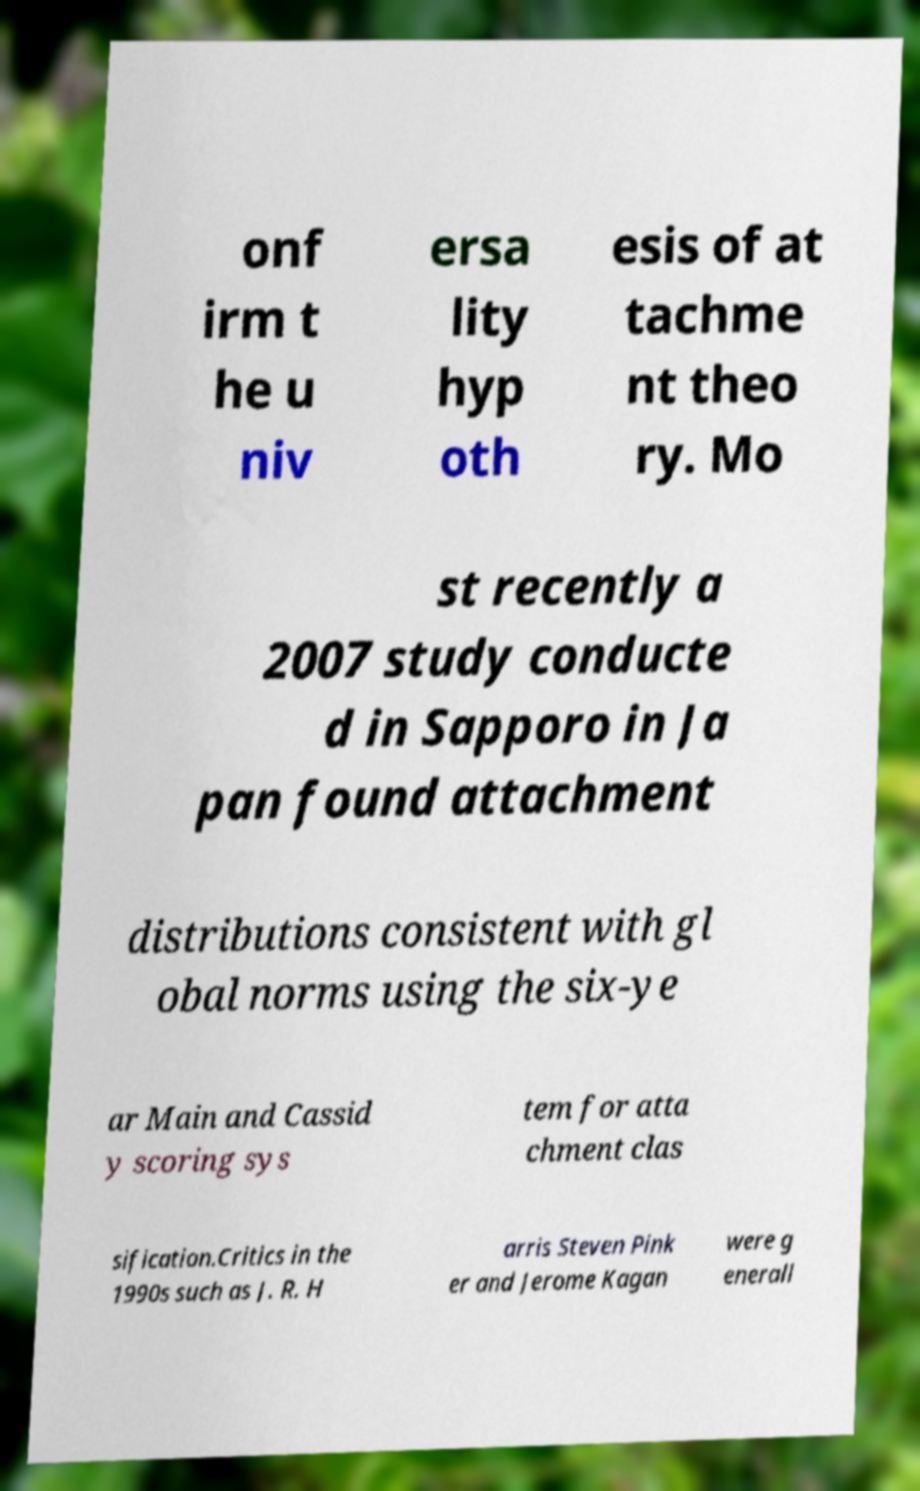Could you extract and type out the text from this image? onf irm t he u niv ersa lity hyp oth esis of at tachme nt theo ry. Mo st recently a 2007 study conducte d in Sapporo in Ja pan found attachment distributions consistent with gl obal norms using the six-ye ar Main and Cassid y scoring sys tem for atta chment clas sification.Critics in the 1990s such as J. R. H arris Steven Pink er and Jerome Kagan were g enerall 